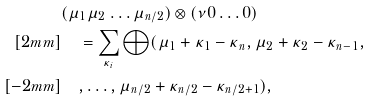Convert formula to latex. <formula><loc_0><loc_0><loc_500><loc_500>& ( \mu _ { 1 } \mu _ { 2 } \dots \mu _ { n / 2 } ) \otimes ( \nu 0 \dots 0 ) \\ [ 2 m m ] & \quad = \sum _ { \kappa _ { i } } \bigoplus ( \mu _ { 1 } + \kappa _ { 1 } - \kappa _ { n } , \mu _ { 2 } + \kappa _ { 2 } - \kappa _ { n - 1 } , \\ [ - 2 m m ] & \quad , \dots , \mu _ { n / 2 } + \kappa _ { n / 2 } - \kappa _ { n / 2 + 1 } ) ,</formula> 